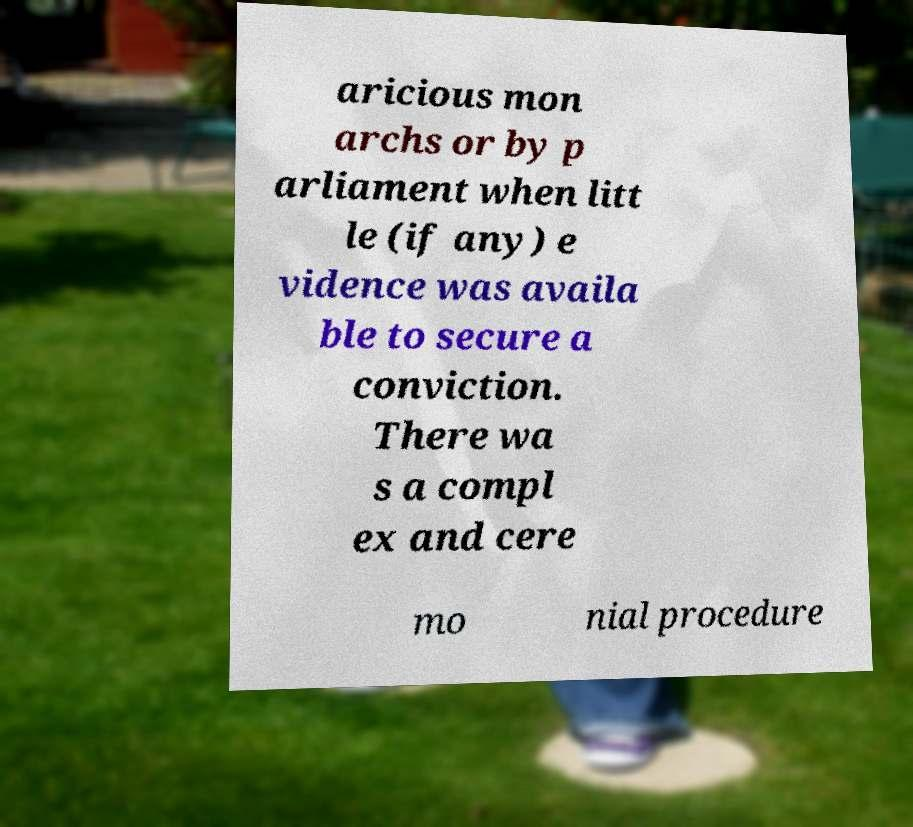Can you accurately transcribe the text from the provided image for me? aricious mon archs or by p arliament when litt le (if any) e vidence was availa ble to secure a conviction. There wa s a compl ex and cere mo nial procedure 